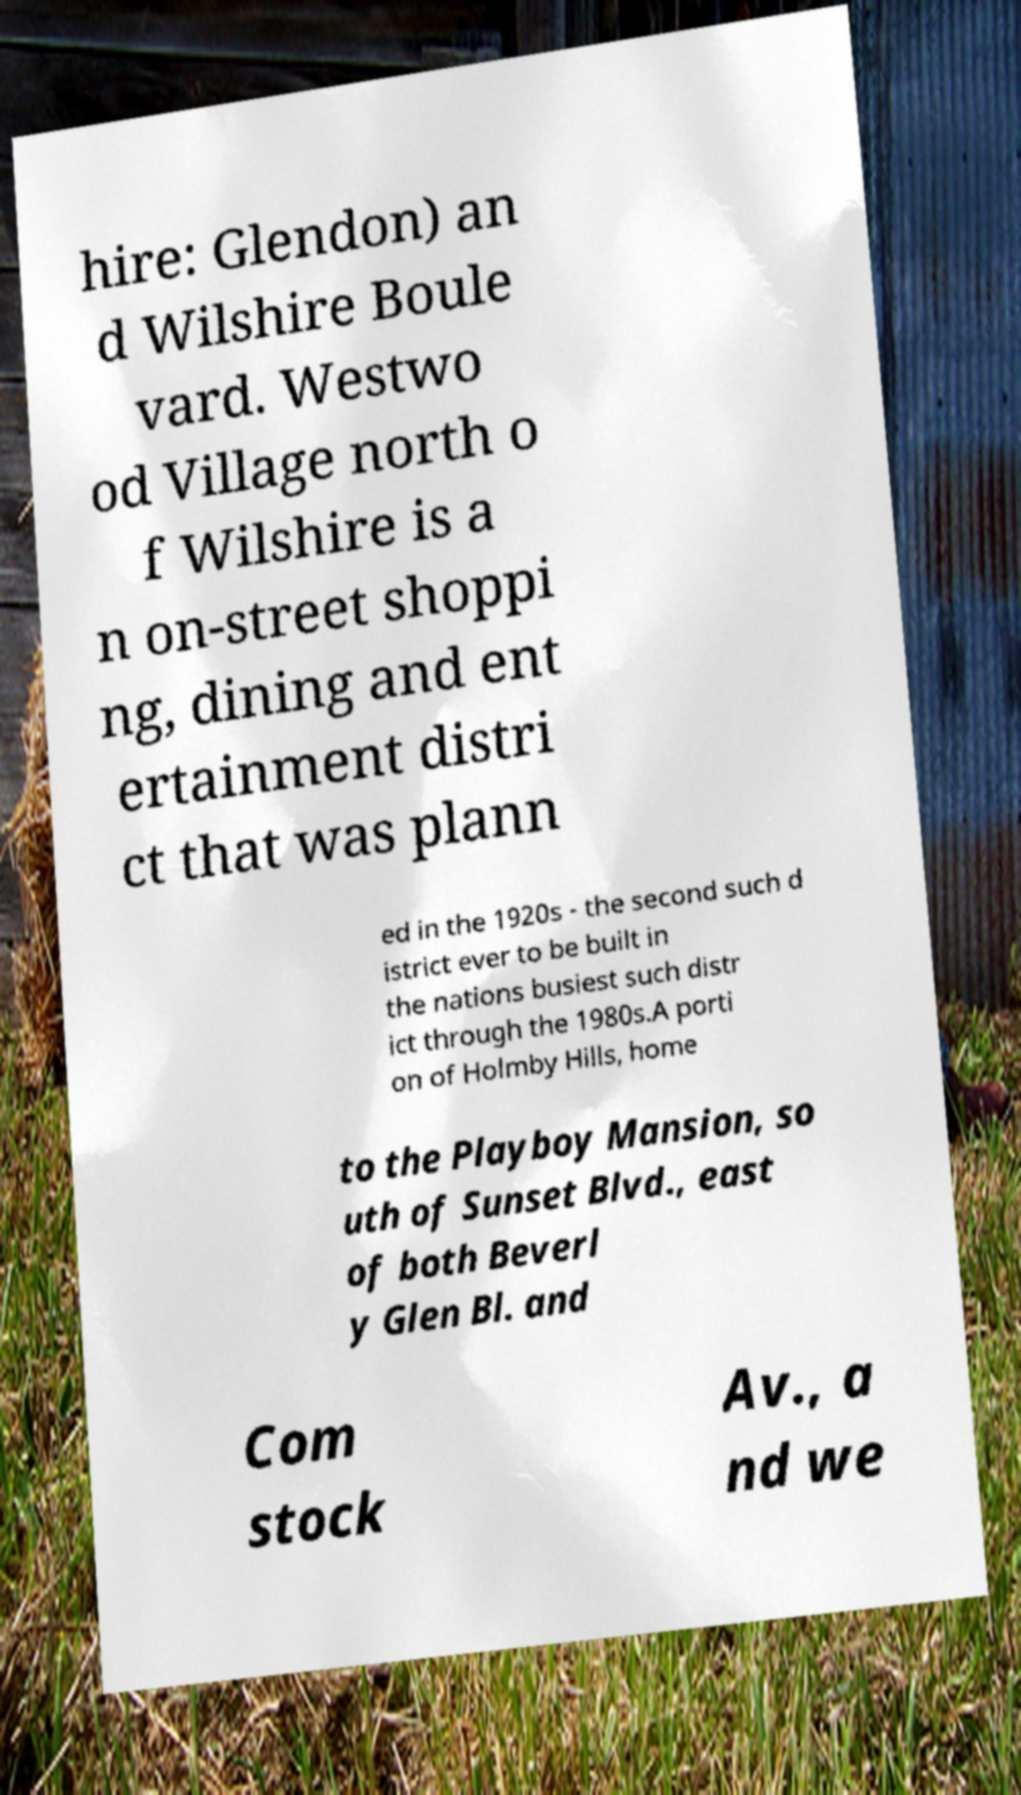What messages or text are displayed in this image? I need them in a readable, typed format. hire: Glendon) an d Wilshire Boule vard. Westwo od Village north o f Wilshire is a n on-street shoppi ng, dining and ent ertainment distri ct that was plann ed in the 1920s - the second such d istrict ever to be built in the nations busiest such distr ict through the 1980s.A porti on of Holmby Hills, home to the Playboy Mansion, so uth of Sunset Blvd., east of both Beverl y Glen Bl. and Com stock Av., a nd we 